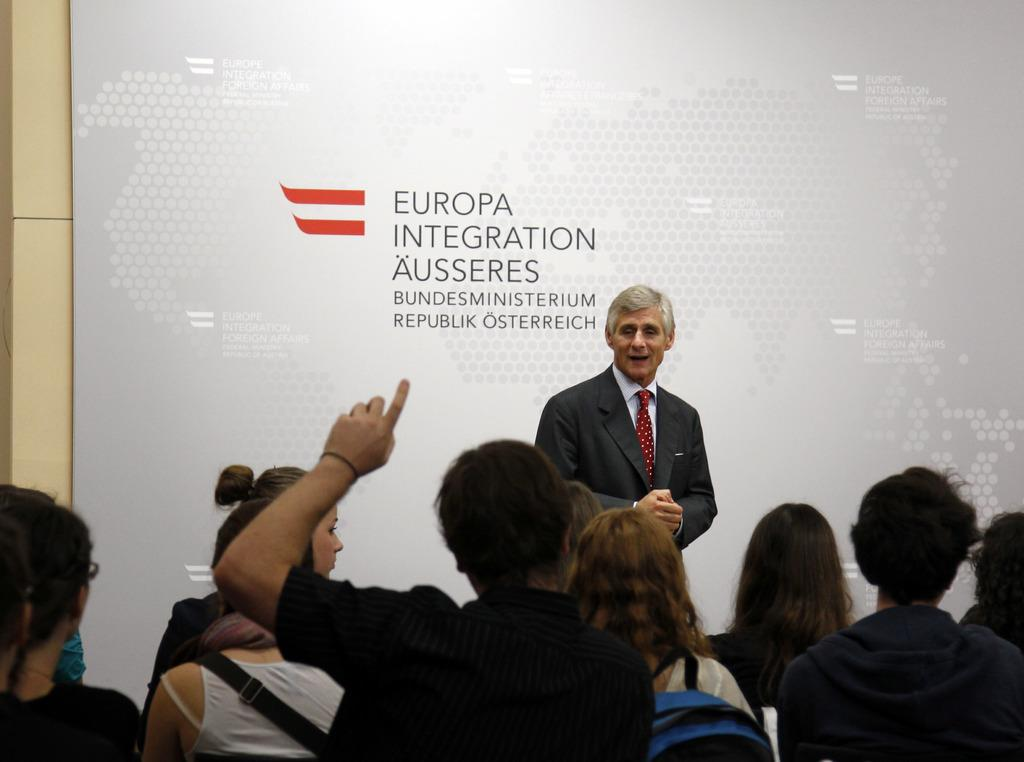Who is present in the image? There is a man in the image. What is the man wearing? The man is wearing a suit. What is the man standing near? The man is standing near a board. What is the position of the other people in the image? There is a group of people sitting on chairs in the image. What type of drain can be seen in the image? There is no drain present in the image. What kind of soup is being served to the people sitting on chairs? There is no soup present in the image. 